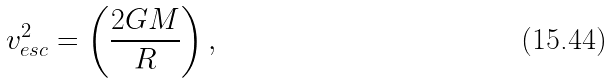<formula> <loc_0><loc_0><loc_500><loc_500>v _ { e s c } ^ { 2 } = \left ( \frac { 2 G M } { R } \right ) ,</formula> 